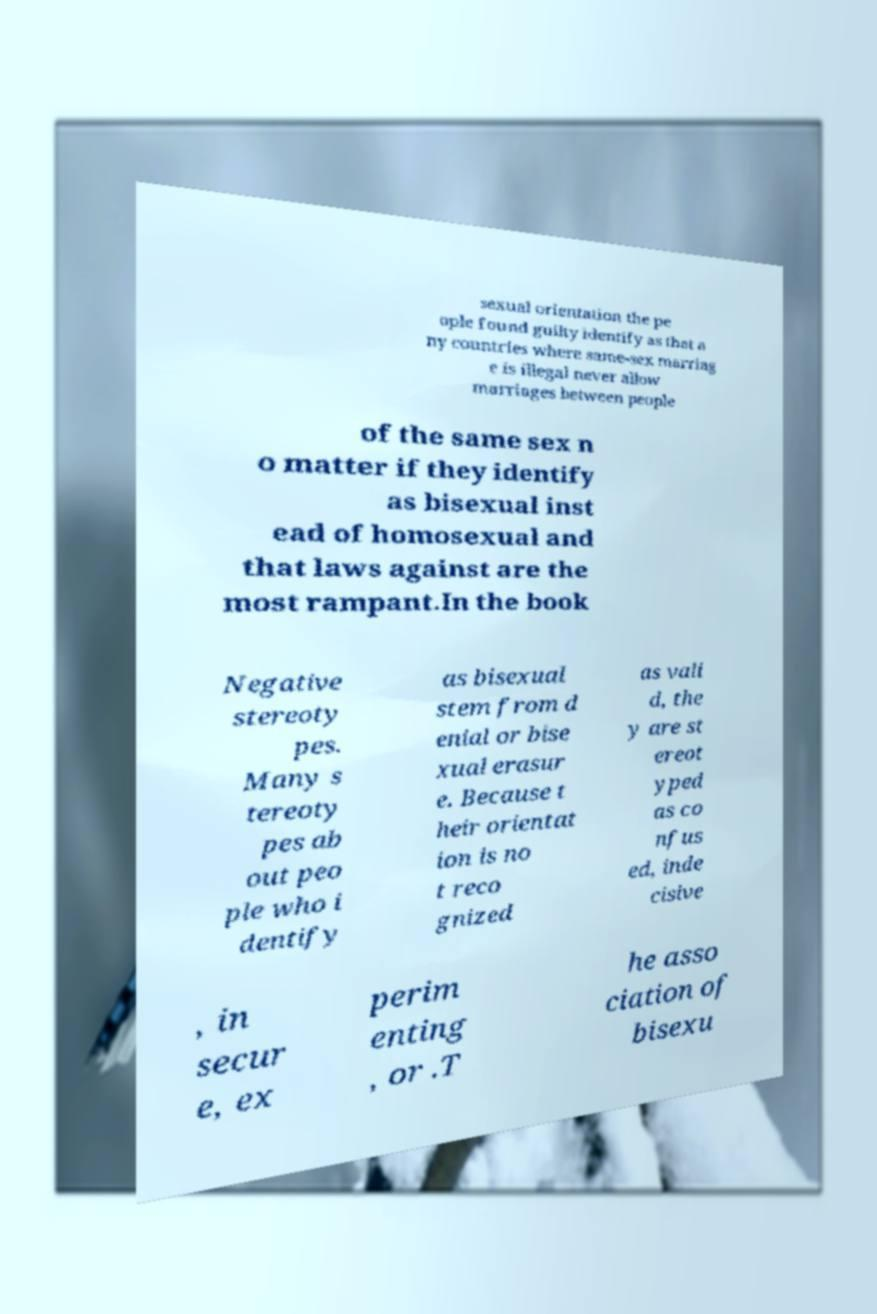Can you read and provide the text displayed in the image?This photo seems to have some interesting text. Can you extract and type it out for me? sexual orientation the pe ople found guilty identify as that a ny countries where same-sex marriag e is illegal never allow marriages between people of the same sex n o matter if they identify as bisexual inst ead of homosexual and that laws against are the most rampant.In the book Negative stereoty pes. Many s tereoty pes ab out peo ple who i dentify as bisexual stem from d enial or bise xual erasur e. Because t heir orientat ion is no t reco gnized as vali d, the y are st ereot yped as co nfus ed, inde cisive , in secur e, ex perim enting , or .T he asso ciation of bisexu 